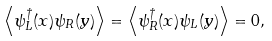<formula> <loc_0><loc_0><loc_500><loc_500>\left \langle { \psi _ { L } ^ { \dagger } ( x ) \psi _ { R } ( y ) } \right \rangle = \left \langle { \psi _ { R } ^ { \dagger } ( x ) \psi _ { L } ( y ) } \right \rangle = 0 ,</formula> 